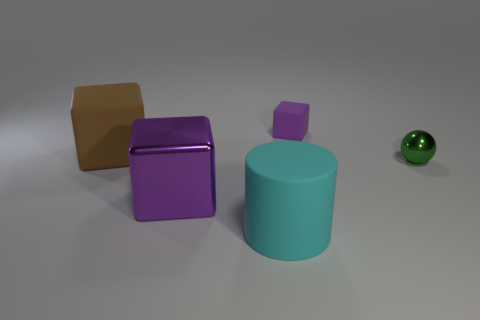Subtract all big purple metallic blocks. How many blocks are left? 2 Add 4 small purple blocks. How many objects exist? 9 Subtract all cubes. How many objects are left? 2 Subtract 1 cubes. How many cubes are left? 2 Subtract all brown cubes. Subtract all brown balls. How many cubes are left? 2 Subtract all brown cylinders. How many purple blocks are left? 2 Subtract all big brown things. Subtract all purple shiny blocks. How many objects are left? 3 Add 3 small green shiny spheres. How many small green shiny spheres are left? 4 Add 1 large blue things. How many large blue things exist? 1 Subtract all brown cubes. How many cubes are left? 2 